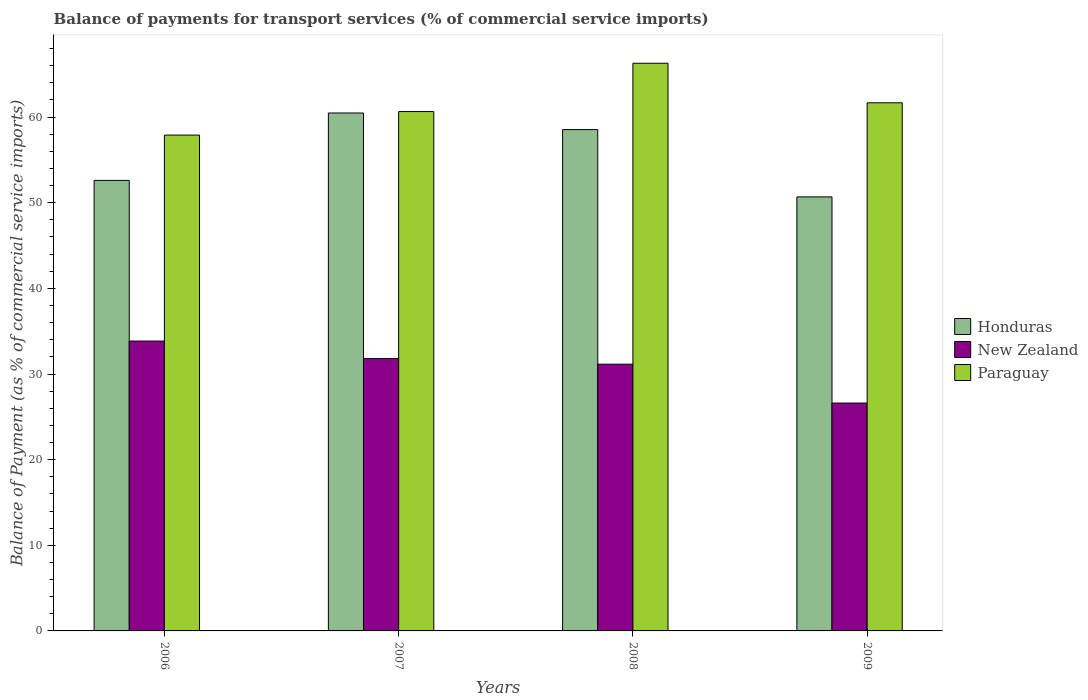How many different coloured bars are there?
Your answer should be compact. 3. How many bars are there on the 4th tick from the left?
Offer a terse response. 3. What is the label of the 4th group of bars from the left?
Offer a terse response. 2009. In how many cases, is the number of bars for a given year not equal to the number of legend labels?
Offer a terse response. 0. What is the balance of payments for transport services in Paraguay in 2008?
Offer a very short reply. 66.29. Across all years, what is the maximum balance of payments for transport services in New Zealand?
Provide a succinct answer. 33.85. Across all years, what is the minimum balance of payments for transport services in New Zealand?
Offer a terse response. 26.61. In which year was the balance of payments for transport services in New Zealand minimum?
Ensure brevity in your answer.  2009. What is the total balance of payments for transport services in Paraguay in the graph?
Your answer should be compact. 246.51. What is the difference between the balance of payments for transport services in Honduras in 2006 and that in 2007?
Your response must be concise. -7.87. What is the difference between the balance of payments for transport services in Paraguay in 2007 and the balance of payments for transport services in New Zealand in 2009?
Make the answer very short. 34.04. What is the average balance of payments for transport services in Paraguay per year?
Give a very brief answer. 61.63. In the year 2008, what is the difference between the balance of payments for transport services in Honduras and balance of payments for transport services in New Zealand?
Your response must be concise. 27.39. In how many years, is the balance of payments for transport services in Paraguay greater than 50 %?
Make the answer very short. 4. What is the ratio of the balance of payments for transport services in Honduras in 2007 to that in 2009?
Offer a terse response. 1.19. Is the difference between the balance of payments for transport services in Honduras in 2006 and 2009 greater than the difference between the balance of payments for transport services in New Zealand in 2006 and 2009?
Your response must be concise. No. What is the difference between the highest and the second highest balance of payments for transport services in Honduras?
Give a very brief answer. 1.94. What is the difference between the highest and the lowest balance of payments for transport services in Honduras?
Provide a short and direct response. 9.8. In how many years, is the balance of payments for transport services in New Zealand greater than the average balance of payments for transport services in New Zealand taken over all years?
Your answer should be compact. 3. Is the sum of the balance of payments for transport services in New Zealand in 2006 and 2009 greater than the maximum balance of payments for transport services in Honduras across all years?
Give a very brief answer. No. What does the 3rd bar from the left in 2009 represents?
Offer a terse response. Paraguay. What does the 3rd bar from the right in 2008 represents?
Give a very brief answer. Honduras. Is it the case that in every year, the sum of the balance of payments for transport services in Paraguay and balance of payments for transport services in New Zealand is greater than the balance of payments for transport services in Honduras?
Make the answer very short. Yes. How many bars are there?
Your response must be concise. 12. How many legend labels are there?
Provide a short and direct response. 3. How are the legend labels stacked?
Your answer should be very brief. Vertical. What is the title of the graph?
Make the answer very short. Balance of payments for transport services (% of commercial service imports). Does "Congo (Republic)" appear as one of the legend labels in the graph?
Your response must be concise. No. What is the label or title of the X-axis?
Offer a terse response. Years. What is the label or title of the Y-axis?
Your response must be concise. Balance of Payment (as % of commercial service imports). What is the Balance of Payment (as % of commercial service imports) of Honduras in 2006?
Provide a short and direct response. 52.61. What is the Balance of Payment (as % of commercial service imports) of New Zealand in 2006?
Provide a succinct answer. 33.85. What is the Balance of Payment (as % of commercial service imports) in Paraguay in 2006?
Offer a terse response. 57.9. What is the Balance of Payment (as % of commercial service imports) in Honduras in 2007?
Offer a very short reply. 60.48. What is the Balance of Payment (as % of commercial service imports) of New Zealand in 2007?
Offer a terse response. 31.8. What is the Balance of Payment (as % of commercial service imports) of Paraguay in 2007?
Your answer should be compact. 60.65. What is the Balance of Payment (as % of commercial service imports) in Honduras in 2008?
Keep it short and to the point. 58.54. What is the Balance of Payment (as % of commercial service imports) in New Zealand in 2008?
Provide a short and direct response. 31.15. What is the Balance of Payment (as % of commercial service imports) in Paraguay in 2008?
Keep it short and to the point. 66.29. What is the Balance of Payment (as % of commercial service imports) of Honduras in 2009?
Give a very brief answer. 50.68. What is the Balance of Payment (as % of commercial service imports) in New Zealand in 2009?
Offer a terse response. 26.61. What is the Balance of Payment (as % of commercial service imports) of Paraguay in 2009?
Keep it short and to the point. 61.67. Across all years, what is the maximum Balance of Payment (as % of commercial service imports) in Honduras?
Offer a terse response. 60.48. Across all years, what is the maximum Balance of Payment (as % of commercial service imports) of New Zealand?
Your answer should be very brief. 33.85. Across all years, what is the maximum Balance of Payment (as % of commercial service imports) in Paraguay?
Give a very brief answer. 66.29. Across all years, what is the minimum Balance of Payment (as % of commercial service imports) in Honduras?
Ensure brevity in your answer.  50.68. Across all years, what is the minimum Balance of Payment (as % of commercial service imports) of New Zealand?
Offer a terse response. 26.61. Across all years, what is the minimum Balance of Payment (as % of commercial service imports) in Paraguay?
Your answer should be compact. 57.9. What is the total Balance of Payment (as % of commercial service imports) in Honduras in the graph?
Your answer should be very brief. 222.32. What is the total Balance of Payment (as % of commercial service imports) in New Zealand in the graph?
Give a very brief answer. 123.41. What is the total Balance of Payment (as % of commercial service imports) in Paraguay in the graph?
Keep it short and to the point. 246.51. What is the difference between the Balance of Payment (as % of commercial service imports) in Honduras in 2006 and that in 2007?
Ensure brevity in your answer.  -7.87. What is the difference between the Balance of Payment (as % of commercial service imports) in New Zealand in 2006 and that in 2007?
Give a very brief answer. 2.04. What is the difference between the Balance of Payment (as % of commercial service imports) in Paraguay in 2006 and that in 2007?
Provide a succinct answer. -2.75. What is the difference between the Balance of Payment (as % of commercial service imports) of Honduras in 2006 and that in 2008?
Ensure brevity in your answer.  -5.93. What is the difference between the Balance of Payment (as % of commercial service imports) of New Zealand in 2006 and that in 2008?
Offer a very short reply. 2.7. What is the difference between the Balance of Payment (as % of commercial service imports) of Paraguay in 2006 and that in 2008?
Keep it short and to the point. -8.39. What is the difference between the Balance of Payment (as % of commercial service imports) of Honduras in 2006 and that in 2009?
Your answer should be compact. 1.93. What is the difference between the Balance of Payment (as % of commercial service imports) in New Zealand in 2006 and that in 2009?
Ensure brevity in your answer.  7.24. What is the difference between the Balance of Payment (as % of commercial service imports) of Paraguay in 2006 and that in 2009?
Ensure brevity in your answer.  -3.77. What is the difference between the Balance of Payment (as % of commercial service imports) of Honduras in 2007 and that in 2008?
Provide a succinct answer. 1.94. What is the difference between the Balance of Payment (as % of commercial service imports) in New Zealand in 2007 and that in 2008?
Your answer should be compact. 0.66. What is the difference between the Balance of Payment (as % of commercial service imports) of Paraguay in 2007 and that in 2008?
Your answer should be compact. -5.64. What is the difference between the Balance of Payment (as % of commercial service imports) in Honduras in 2007 and that in 2009?
Your response must be concise. 9.8. What is the difference between the Balance of Payment (as % of commercial service imports) of New Zealand in 2007 and that in 2009?
Offer a terse response. 5.2. What is the difference between the Balance of Payment (as % of commercial service imports) of Paraguay in 2007 and that in 2009?
Offer a very short reply. -1.02. What is the difference between the Balance of Payment (as % of commercial service imports) of Honduras in 2008 and that in 2009?
Give a very brief answer. 7.86. What is the difference between the Balance of Payment (as % of commercial service imports) of New Zealand in 2008 and that in 2009?
Make the answer very short. 4.54. What is the difference between the Balance of Payment (as % of commercial service imports) of Paraguay in 2008 and that in 2009?
Provide a succinct answer. 4.62. What is the difference between the Balance of Payment (as % of commercial service imports) of Honduras in 2006 and the Balance of Payment (as % of commercial service imports) of New Zealand in 2007?
Keep it short and to the point. 20.81. What is the difference between the Balance of Payment (as % of commercial service imports) of Honduras in 2006 and the Balance of Payment (as % of commercial service imports) of Paraguay in 2007?
Provide a short and direct response. -8.04. What is the difference between the Balance of Payment (as % of commercial service imports) of New Zealand in 2006 and the Balance of Payment (as % of commercial service imports) of Paraguay in 2007?
Your response must be concise. -26.8. What is the difference between the Balance of Payment (as % of commercial service imports) in Honduras in 2006 and the Balance of Payment (as % of commercial service imports) in New Zealand in 2008?
Keep it short and to the point. 21.46. What is the difference between the Balance of Payment (as % of commercial service imports) of Honduras in 2006 and the Balance of Payment (as % of commercial service imports) of Paraguay in 2008?
Provide a succinct answer. -13.68. What is the difference between the Balance of Payment (as % of commercial service imports) of New Zealand in 2006 and the Balance of Payment (as % of commercial service imports) of Paraguay in 2008?
Your answer should be compact. -32.44. What is the difference between the Balance of Payment (as % of commercial service imports) of Honduras in 2006 and the Balance of Payment (as % of commercial service imports) of New Zealand in 2009?
Give a very brief answer. 26. What is the difference between the Balance of Payment (as % of commercial service imports) in Honduras in 2006 and the Balance of Payment (as % of commercial service imports) in Paraguay in 2009?
Provide a succinct answer. -9.06. What is the difference between the Balance of Payment (as % of commercial service imports) of New Zealand in 2006 and the Balance of Payment (as % of commercial service imports) of Paraguay in 2009?
Provide a succinct answer. -27.83. What is the difference between the Balance of Payment (as % of commercial service imports) of Honduras in 2007 and the Balance of Payment (as % of commercial service imports) of New Zealand in 2008?
Provide a short and direct response. 29.33. What is the difference between the Balance of Payment (as % of commercial service imports) of Honduras in 2007 and the Balance of Payment (as % of commercial service imports) of Paraguay in 2008?
Offer a terse response. -5.81. What is the difference between the Balance of Payment (as % of commercial service imports) of New Zealand in 2007 and the Balance of Payment (as % of commercial service imports) of Paraguay in 2008?
Your answer should be very brief. -34.48. What is the difference between the Balance of Payment (as % of commercial service imports) in Honduras in 2007 and the Balance of Payment (as % of commercial service imports) in New Zealand in 2009?
Your answer should be compact. 33.87. What is the difference between the Balance of Payment (as % of commercial service imports) in Honduras in 2007 and the Balance of Payment (as % of commercial service imports) in Paraguay in 2009?
Provide a short and direct response. -1.19. What is the difference between the Balance of Payment (as % of commercial service imports) of New Zealand in 2007 and the Balance of Payment (as % of commercial service imports) of Paraguay in 2009?
Give a very brief answer. -29.87. What is the difference between the Balance of Payment (as % of commercial service imports) in Honduras in 2008 and the Balance of Payment (as % of commercial service imports) in New Zealand in 2009?
Keep it short and to the point. 31.93. What is the difference between the Balance of Payment (as % of commercial service imports) in Honduras in 2008 and the Balance of Payment (as % of commercial service imports) in Paraguay in 2009?
Ensure brevity in your answer.  -3.13. What is the difference between the Balance of Payment (as % of commercial service imports) in New Zealand in 2008 and the Balance of Payment (as % of commercial service imports) in Paraguay in 2009?
Make the answer very short. -30.52. What is the average Balance of Payment (as % of commercial service imports) of Honduras per year?
Keep it short and to the point. 55.58. What is the average Balance of Payment (as % of commercial service imports) of New Zealand per year?
Ensure brevity in your answer.  30.85. What is the average Balance of Payment (as % of commercial service imports) of Paraguay per year?
Offer a terse response. 61.63. In the year 2006, what is the difference between the Balance of Payment (as % of commercial service imports) in Honduras and Balance of Payment (as % of commercial service imports) in New Zealand?
Provide a short and direct response. 18.77. In the year 2006, what is the difference between the Balance of Payment (as % of commercial service imports) of Honduras and Balance of Payment (as % of commercial service imports) of Paraguay?
Your answer should be very brief. -5.29. In the year 2006, what is the difference between the Balance of Payment (as % of commercial service imports) in New Zealand and Balance of Payment (as % of commercial service imports) in Paraguay?
Make the answer very short. -24.05. In the year 2007, what is the difference between the Balance of Payment (as % of commercial service imports) of Honduras and Balance of Payment (as % of commercial service imports) of New Zealand?
Provide a succinct answer. 28.68. In the year 2007, what is the difference between the Balance of Payment (as % of commercial service imports) of Honduras and Balance of Payment (as % of commercial service imports) of Paraguay?
Give a very brief answer. -0.17. In the year 2007, what is the difference between the Balance of Payment (as % of commercial service imports) in New Zealand and Balance of Payment (as % of commercial service imports) in Paraguay?
Your answer should be very brief. -28.84. In the year 2008, what is the difference between the Balance of Payment (as % of commercial service imports) of Honduras and Balance of Payment (as % of commercial service imports) of New Zealand?
Ensure brevity in your answer.  27.39. In the year 2008, what is the difference between the Balance of Payment (as % of commercial service imports) in Honduras and Balance of Payment (as % of commercial service imports) in Paraguay?
Keep it short and to the point. -7.75. In the year 2008, what is the difference between the Balance of Payment (as % of commercial service imports) in New Zealand and Balance of Payment (as % of commercial service imports) in Paraguay?
Ensure brevity in your answer.  -35.14. In the year 2009, what is the difference between the Balance of Payment (as % of commercial service imports) in Honduras and Balance of Payment (as % of commercial service imports) in New Zealand?
Ensure brevity in your answer.  24.07. In the year 2009, what is the difference between the Balance of Payment (as % of commercial service imports) of Honduras and Balance of Payment (as % of commercial service imports) of Paraguay?
Ensure brevity in your answer.  -10.99. In the year 2009, what is the difference between the Balance of Payment (as % of commercial service imports) in New Zealand and Balance of Payment (as % of commercial service imports) in Paraguay?
Offer a terse response. -35.06. What is the ratio of the Balance of Payment (as % of commercial service imports) in Honduras in 2006 to that in 2007?
Your answer should be compact. 0.87. What is the ratio of the Balance of Payment (as % of commercial service imports) of New Zealand in 2006 to that in 2007?
Ensure brevity in your answer.  1.06. What is the ratio of the Balance of Payment (as % of commercial service imports) in Paraguay in 2006 to that in 2007?
Make the answer very short. 0.95. What is the ratio of the Balance of Payment (as % of commercial service imports) of Honduras in 2006 to that in 2008?
Offer a very short reply. 0.9. What is the ratio of the Balance of Payment (as % of commercial service imports) in New Zealand in 2006 to that in 2008?
Make the answer very short. 1.09. What is the ratio of the Balance of Payment (as % of commercial service imports) in Paraguay in 2006 to that in 2008?
Provide a short and direct response. 0.87. What is the ratio of the Balance of Payment (as % of commercial service imports) in Honduras in 2006 to that in 2009?
Your answer should be compact. 1.04. What is the ratio of the Balance of Payment (as % of commercial service imports) of New Zealand in 2006 to that in 2009?
Offer a terse response. 1.27. What is the ratio of the Balance of Payment (as % of commercial service imports) in Paraguay in 2006 to that in 2009?
Your answer should be compact. 0.94. What is the ratio of the Balance of Payment (as % of commercial service imports) in Honduras in 2007 to that in 2008?
Your answer should be compact. 1.03. What is the ratio of the Balance of Payment (as % of commercial service imports) of New Zealand in 2007 to that in 2008?
Provide a succinct answer. 1.02. What is the ratio of the Balance of Payment (as % of commercial service imports) in Paraguay in 2007 to that in 2008?
Make the answer very short. 0.91. What is the ratio of the Balance of Payment (as % of commercial service imports) in Honduras in 2007 to that in 2009?
Your answer should be compact. 1.19. What is the ratio of the Balance of Payment (as % of commercial service imports) in New Zealand in 2007 to that in 2009?
Provide a succinct answer. 1.2. What is the ratio of the Balance of Payment (as % of commercial service imports) of Paraguay in 2007 to that in 2009?
Offer a very short reply. 0.98. What is the ratio of the Balance of Payment (as % of commercial service imports) of Honduras in 2008 to that in 2009?
Your answer should be very brief. 1.16. What is the ratio of the Balance of Payment (as % of commercial service imports) of New Zealand in 2008 to that in 2009?
Ensure brevity in your answer.  1.17. What is the ratio of the Balance of Payment (as % of commercial service imports) in Paraguay in 2008 to that in 2009?
Your response must be concise. 1.07. What is the difference between the highest and the second highest Balance of Payment (as % of commercial service imports) in Honduras?
Ensure brevity in your answer.  1.94. What is the difference between the highest and the second highest Balance of Payment (as % of commercial service imports) in New Zealand?
Make the answer very short. 2.04. What is the difference between the highest and the second highest Balance of Payment (as % of commercial service imports) in Paraguay?
Make the answer very short. 4.62. What is the difference between the highest and the lowest Balance of Payment (as % of commercial service imports) of Honduras?
Your answer should be very brief. 9.8. What is the difference between the highest and the lowest Balance of Payment (as % of commercial service imports) of New Zealand?
Provide a succinct answer. 7.24. What is the difference between the highest and the lowest Balance of Payment (as % of commercial service imports) in Paraguay?
Your answer should be compact. 8.39. 